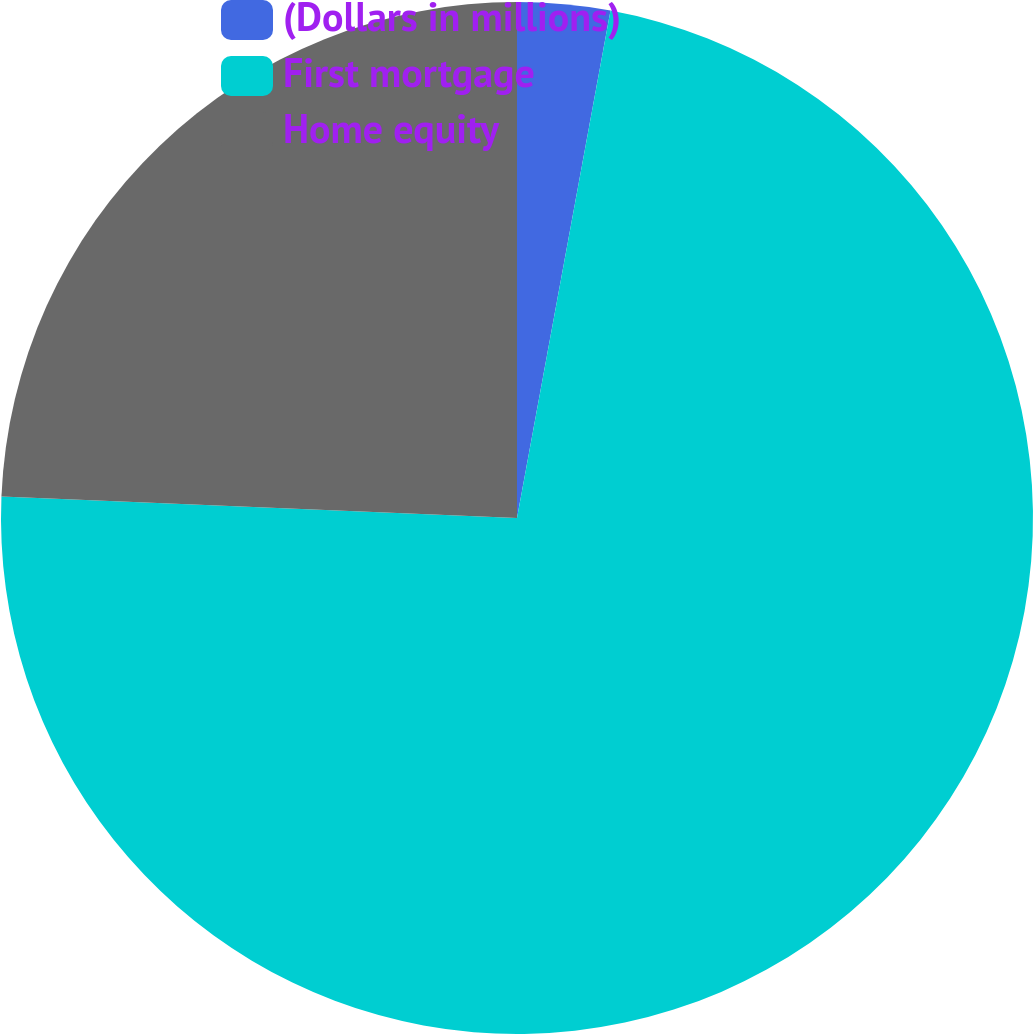Convert chart. <chart><loc_0><loc_0><loc_500><loc_500><pie_chart><fcel>(Dollars in millions)<fcel>First mortgage<fcel>Home equity<nl><fcel>2.9%<fcel>72.76%<fcel>24.34%<nl></chart> 